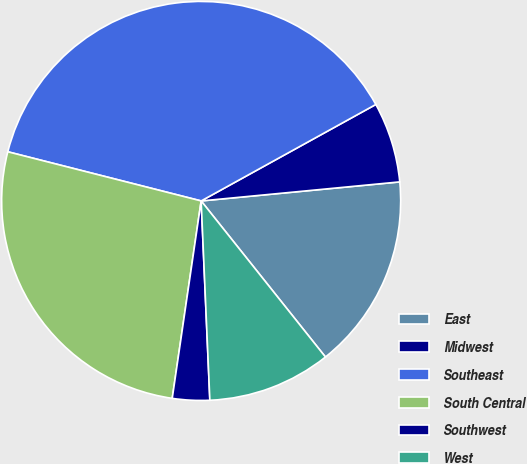<chart> <loc_0><loc_0><loc_500><loc_500><pie_chart><fcel>East<fcel>Midwest<fcel>Southeast<fcel>South Central<fcel>Southwest<fcel>West<nl><fcel>15.82%<fcel>6.51%<fcel>38.01%<fcel>26.65%<fcel>3.01%<fcel>10.01%<nl></chart> 